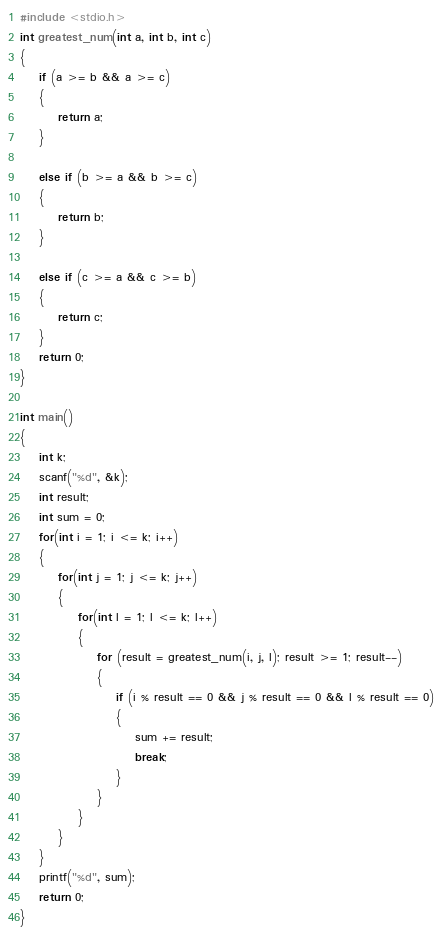Convert code to text. <code><loc_0><loc_0><loc_500><loc_500><_C_>#include <stdio.h>
int greatest_num(int a, int b, int c)
{
    if (a >= b && a >= c)
    {
        return a;
    }

    else if (b >= a && b >= c)
    {
        return b;
    }

    else if (c >= a && c >= b)
    {
        return c;
    }
    return 0;
}

int main()
{
    int k;
    scanf("%d", &k);
    int result;
    int sum = 0;
    for(int i = 1; i <= k; i++)
    {
        for(int j = 1; j <= k; j++)
        {
            for(int l = 1; l <= k; l++)
            {
                for (result = greatest_num(i, j, l); result >= 1; result--)
                {
                    if (i % result == 0 && j % result == 0 && l % result == 0)
                    {
                        sum += result;
                        break;
                    }
                }
            }
        }
    }
    printf("%d", sum);
    return 0;
}</code> 